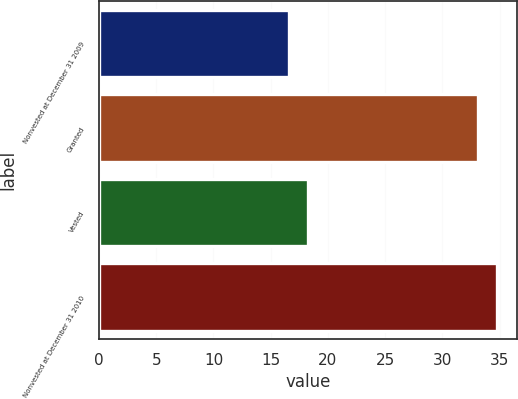<chart> <loc_0><loc_0><loc_500><loc_500><bar_chart><fcel>Nonvested at December 31 2009<fcel>Granted<fcel>Vested<fcel>Nonvested at December 31 2010<nl><fcel>16.58<fcel>33.13<fcel>18.23<fcel>34.79<nl></chart> 